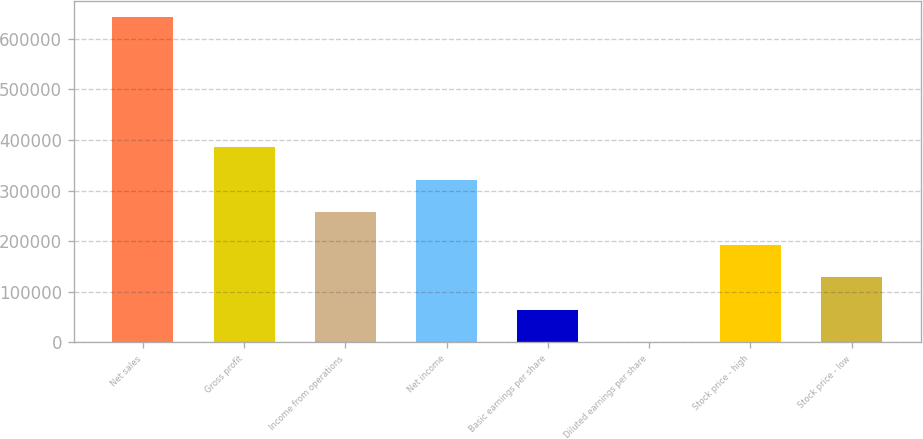Convert chart to OTSL. <chart><loc_0><loc_0><loc_500><loc_500><bar_chart><fcel>Net sales<fcel>Gross profit<fcel>Income from operations<fcel>Net income<fcel>Basic earnings per share<fcel>Diluted earnings per share<fcel>Stock price - high<fcel>Stock price - low<nl><fcel>642764<fcel>385659<fcel>257106<fcel>321382<fcel>64277.2<fcel>0.91<fcel>192830<fcel>128554<nl></chart> 